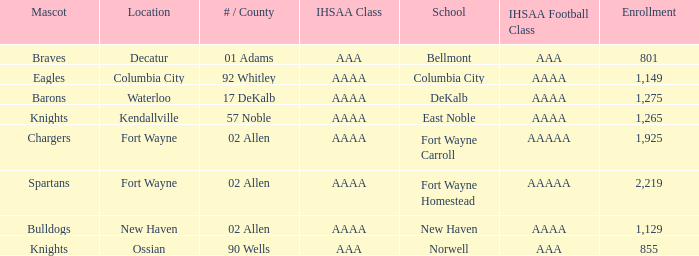What's the enrollment for Kendallville? 1265.0. 